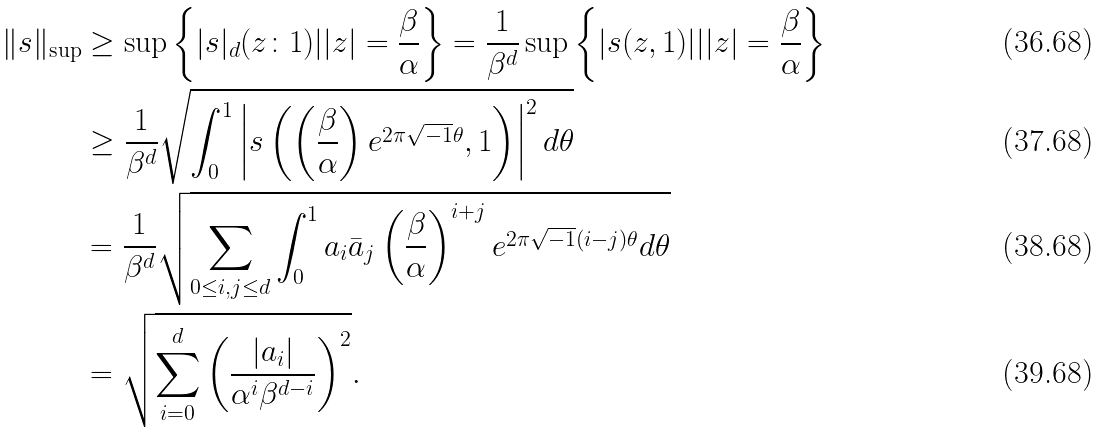<formula> <loc_0><loc_0><loc_500><loc_500>\| s \| _ { \sup } & \geq \sup \left \{ | s | _ { d } ( z \colon 1 ) | | z | = \frac { \beta } { \alpha } \right \} = \frac { 1 } { \beta ^ { d } } \sup \left \{ | s ( z , 1 ) | | | z | = \frac { \beta } { \alpha } \right \} \\ & \geq \frac { 1 } { \beta ^ { d } } \sqrt { \int _ { 0 } ^ { 1 } \left | s \left ( \left ( \frac { \beta } { \alpha } \right ) e ^ { 2 \pi \sqrt { - 1 } \theta } , 1 \right ) \right | ^ { 2 } d \theta } \\ & = \frac { 1 } { \beta ^ { d } } \sqrt { \sum _ { 0 \leq i , j \leq d } \int _ { 0 } ^ { 1 } a _ { i } \bar { a } _ { j } \left ( \frac { \beta } { \alpha } \right ) ^ { i + j } e ^ { 2 \pi \sqrt { - 1 } ( i - j ) \theta } d \theta } \\ & = \sqrt { \sum _ { i = 0 } ^ { d } \left ( \frac { | a _ { i } | } { \alpha ^ { i } \beta ^ { d - i } } \right ) ^ { 2 } } .</formula> 